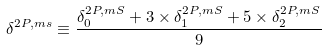Convert formula to latex. <formula><loc_0><loc_0><loc_500><loc_500>\delta ^ { 2 P , m s } \equiv \frac { \delta _ { 0 } ^ { 2 P , m S } + 3 \times \delta _ { 1 } ^ { 2 P , m S } + 5 \times \delta _ { 2 } ^ { 2 P , m S } } { 9 }</formula> 